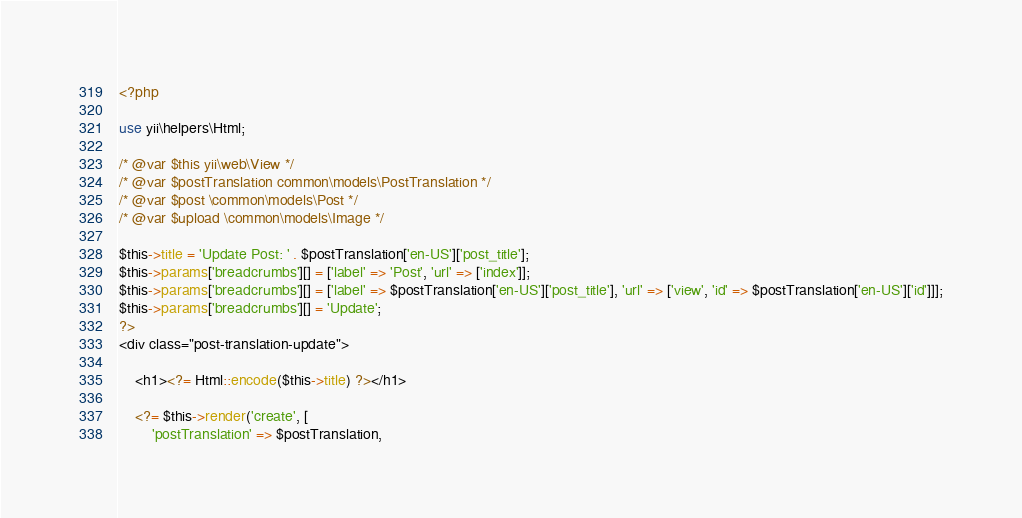<code> <loc_0><loc_0><loc_500><loc_500><_PHP_><?php

use yii\helpers\Html;

/* @var $this yii\web\View */
/* @var $postTranslation common\models\PostTranslation */
/* @var $post \common\models\Post */
/* @var $upload \common\models\Image */

$this->title = 'Update Post: ' . $postTranslation['en-US']['post_title'];
$this->params['breadcrumbs'][] = ['label' => 'Post', 'url' => ['index']];
$this->params['breadcrumbs'][] = ['label' => $postTranslation['en-US']['post_title'], 'url' => ['view', 'id' => $postTranslation['en-US']['id']]];
$this->params['breadcrumbs'][] = 'Update';
?>
<div class="post-translation-update">

    <h1><?= Html::encode($this->title) ?></h1>

    <?= $this->render('create', [
        'postTranslation' => $postTranslation,</code> 